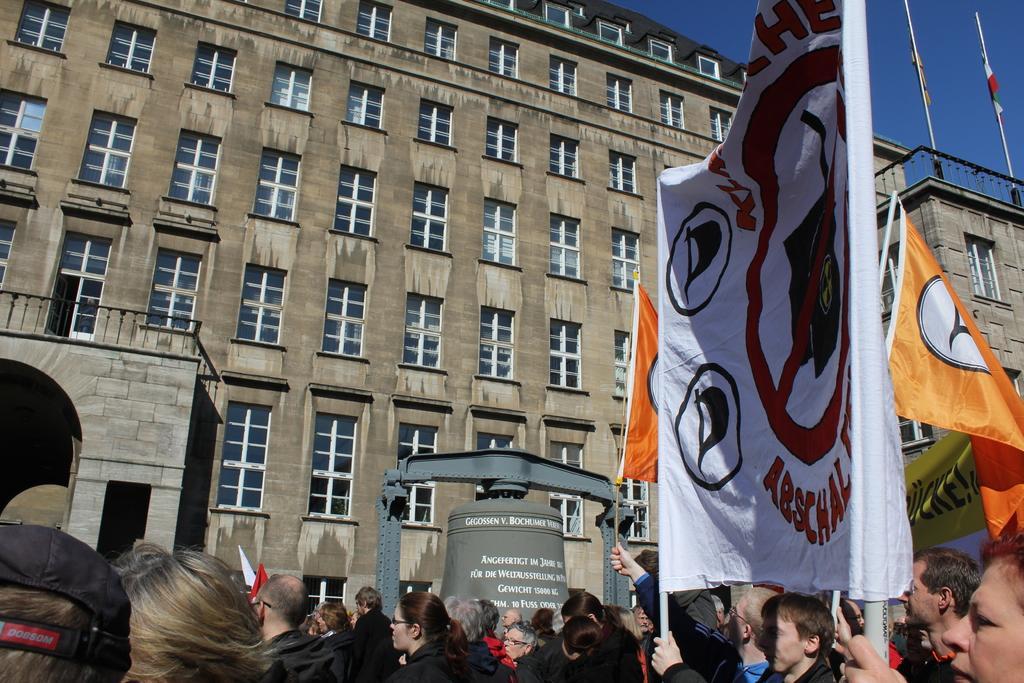Describe this image in one or two sentences. In this image I can see a building , in front of building there is crowd and person holding a banner in the top right I can see two poles and the sky. 